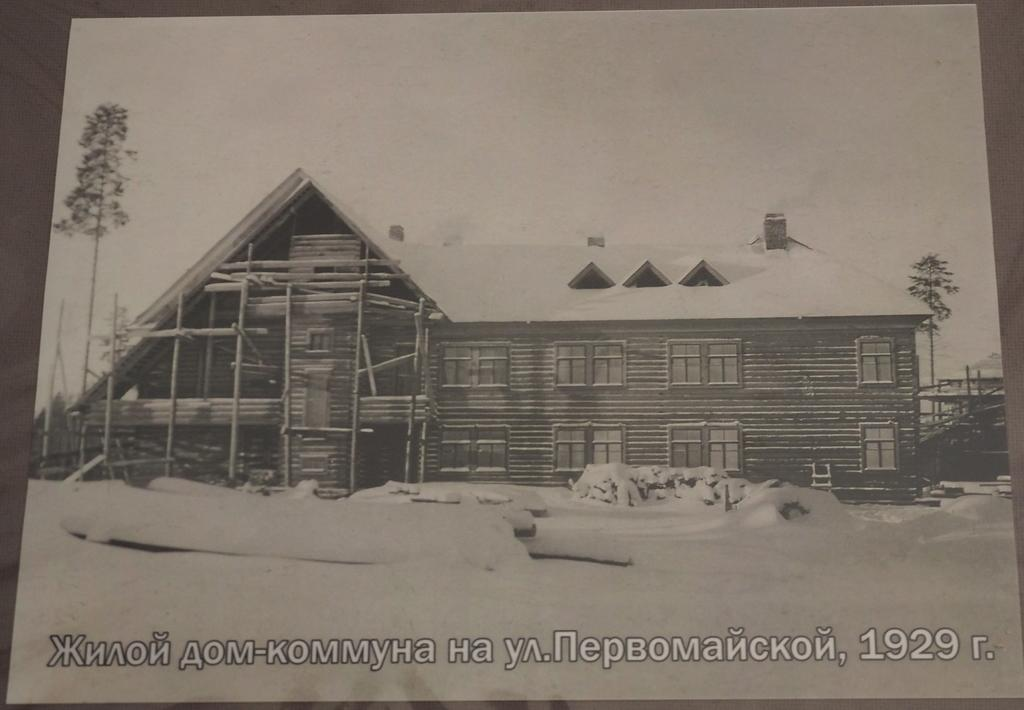What is the color scheme of the image? The image is black and white. What type of structures can be seen in the image? There are buildings in the image. What other natural elements are present in the image? There are trees in the image. What is the weather condition in the image? There is snow visible in the image, indicating a cold or wintery setting. Is there any text present in the image? Yes, there is text written at the bottom of the image. What type of pancake is being served at the daughter's account in the image? There is no mention of a daughter or an account in the image. Additionally, there is no reference to a pancake. 